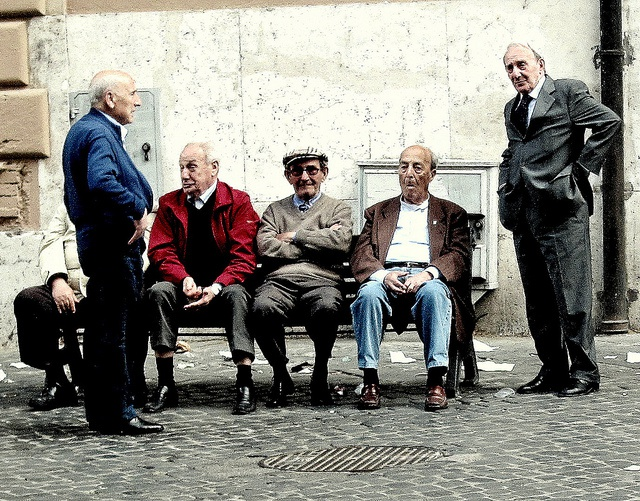Describe the objects in this image and their specific colors. I can see people in tan, black, gray, darkgray, and ivory tones, people in tan, black, navy, ivory, and blue tones, people in tan, black, ivory, gray, and maroon tones, people in tan, black, maroon, brown, and gray tones, and people in tan, black, darkgray, gray, and ivory tones in this image. 